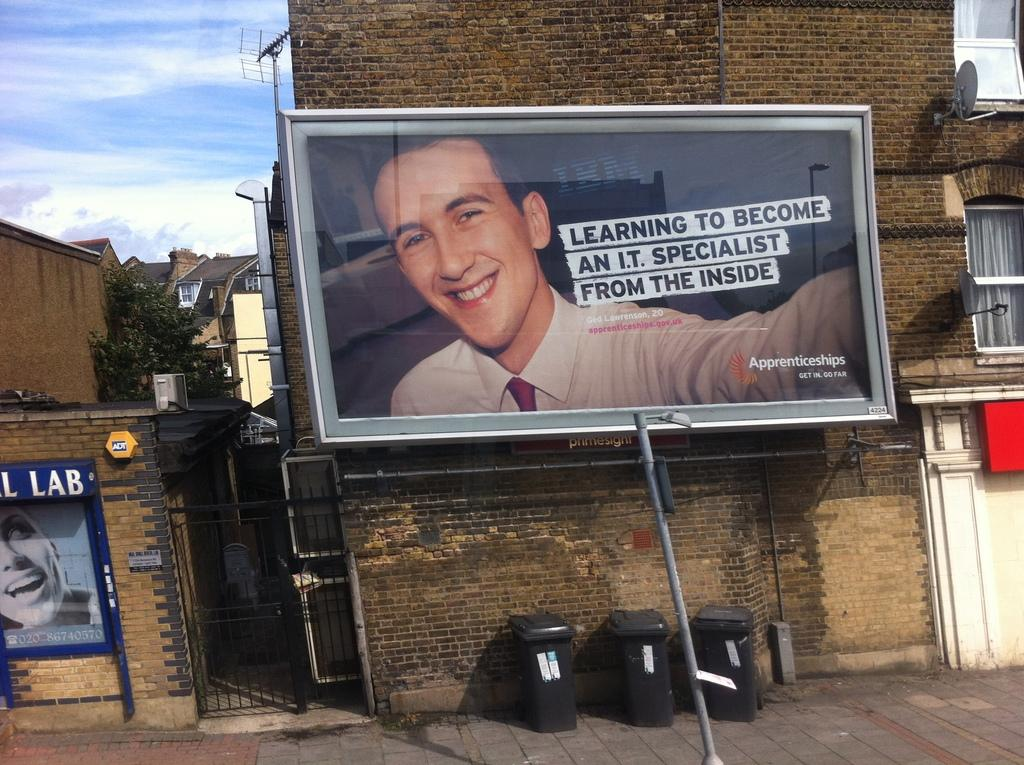<image>
Present a compact description of the photo's key features. A billboard advertising Apprenticeships has the slogun "Learning to become an I.T. specialist from the inside". 